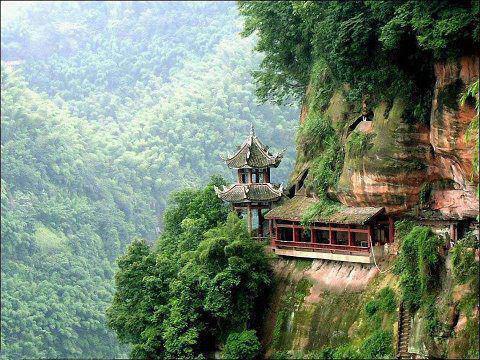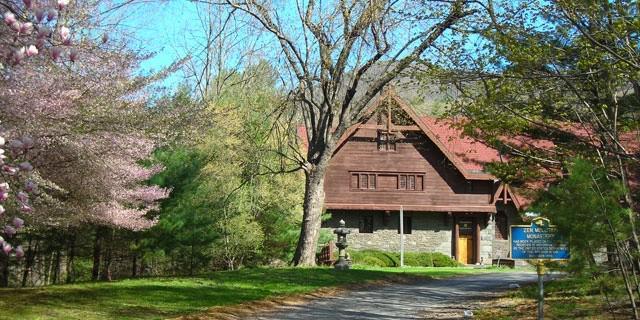The first image is the image on the left, the second image is the image on the right. For the images shown, is this caption "There is a rocky cliff in at least one image." true? Answer yes or no. Yes. 